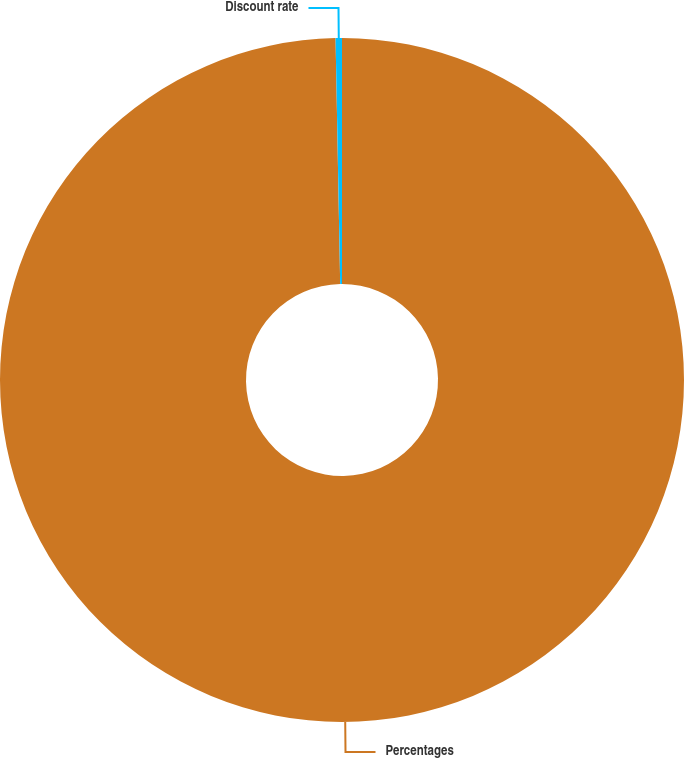<chart> <loc_0><loc_0><loc_500><loc_500><pie_chart><fcel>Percentages<fcel>Discount rate<nl><fcel>99.7%<fcel>0.3%<nl></chart> 